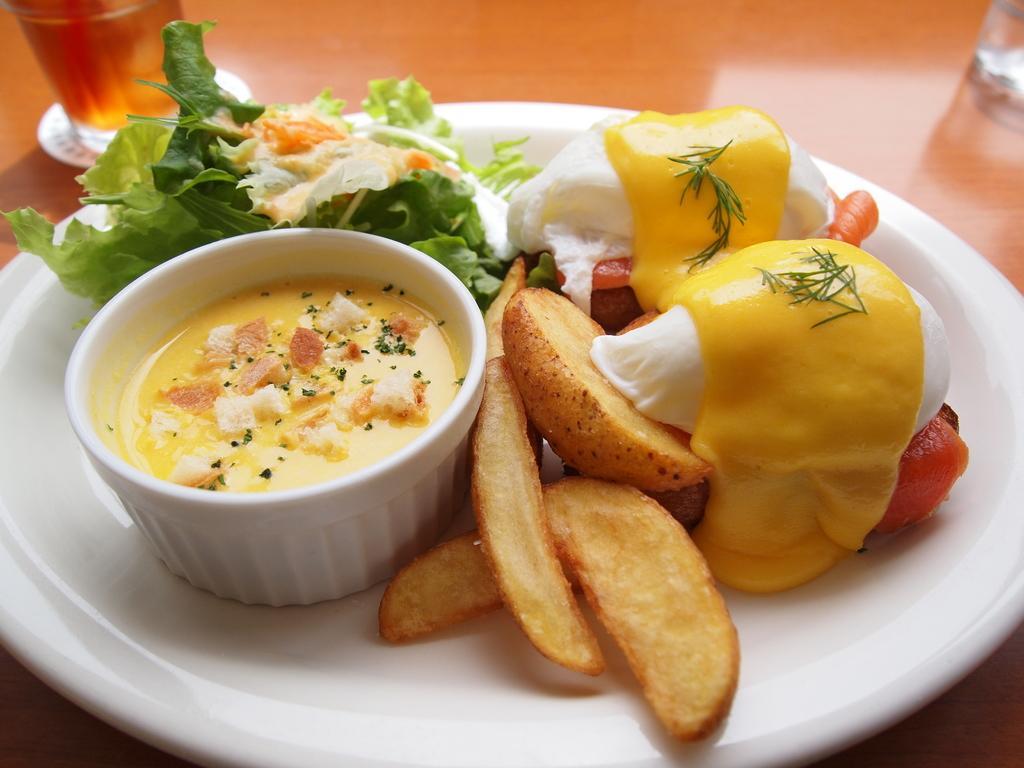In one or two sentences, can you explain what this image depicts? In this picture there is food on the plate and in the bowl. There is a plate and there are glasses on the table. 